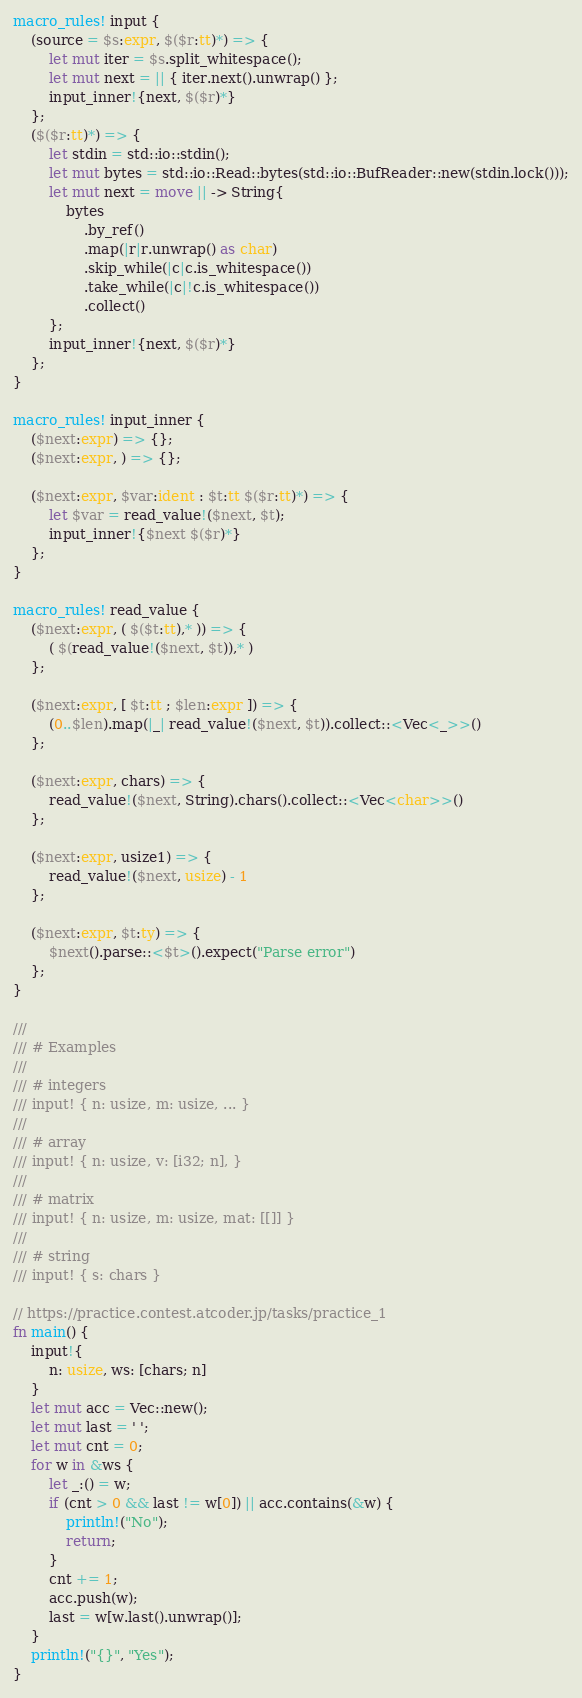Convert code to text. <code><loc_0><loc_0><loc_500><loc_500><_Rust_>macro_rules! input {
    (source = $s:expr, $($r:tt)*) => {
        let mut iter = $s.split_whitespace();
        let mut next = || { iter.next().unwrap() };
        input_inner!{next, $($r)*}
    };
    ($($r:tt)*) => {
        let stdin = std::io::stdin();
        let mut bytes = std::io::Read::bytes(std::io::BufReader::new(stdin.lock()));
        let mut next = move || -> String{
            bytes
                .by_ref()
                .map(|r|r.unwrap() as char)
                .skip_while(|c|c.is_whitespace())
                .take_while(|c|!c.is_whitespace())
                .collect()
        };
        input_inner!{next, $($r)*}
    };
}

macro_rules! input_inner {
    ($next:expr) => {};
    ($next:expr, ) => {};

    ($next:expr, $var:ident : $t:tt $($r:tt)*) => {
        let $var = read_value!($next, $t);
        input_inner!{$next $($r)*}
    };
}

macro_rules! read_value {
    ($next:expr, ( $($t:tt),* )) => {
        ( $(read_value!($next, $t)),* )
    };

    ($next:expr, [ $t:tt ; $len:expr ]) => {
        (0..$len).map(|_| read_value!($next, $t)).collect::<Vec<_>>()
    };

    ($next:expr, chars) => {
        read_value!($next, String).chars().collect::<Vec<char>>()
    };

    ($next:expr, usize1) => {
        read_value!($next, usize) - 1
    };

    ($next:expr, $t:ty) => {
        $next().parse::<$t>().expect("Parse error")
    };
}

///
/// # Examples
///
/// # integers
/// input! { n: usize, m: usize, ... }
///
/// # array
/// input! { n: usize, v: [i32; n], }
///
/// # matrix
/// input! { n: usize, m: usize, mat: [[]] }
///
/// # string
/// input! { s: chars }

// https://practice.contest.atcoder.jp/tasks/practice_1
fn main() {
    input!{
        n: usize, ws: [chars; n]
    }
    let mut acc = Vec::new();
    let mut last = ' ';
    let mut cnt = 0;
    for w in &ws {
        let _:() = w;
        if (cnt > 0 && last != w[0]) || acc.contains(&w) {
            println!("No");
            return;
        }
        cnt += 1;
        acc.push(w);
        last = w[w.last().unwrap()];
    }
    println!("{}", "Yes");
}
</code> 